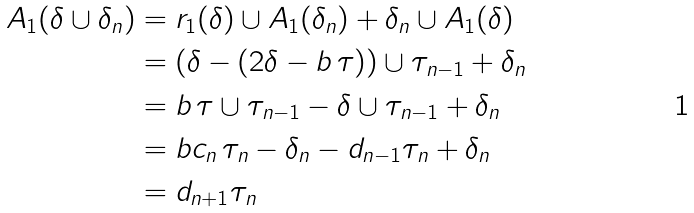Convert formula to latex. <formula><loc_0><loc_0><loc_500><loc_500>A _ { 1 } ( \delta \cup \delta _ { n } ) & = r _ { 1 } ( \delta ) \cup A _ { 1 } ( \delta _ { n } ) + \delta _ { n } \cup A _ { 1 } ( \delta ) \\ & = ( \delta - ( 2 \delta - b \, \tau ) ) \cup \tau _ { n - 1 } + \delta _ { n } \\ & = b \, \tau \cup \tau _ { n - 1 } - \delta \cup \tau _ { n - 1 } + \delta _ { n } \\ & = b c _ { n } \, \tau _ { n } - \delta _ { n } - d _ { n - 1 } \tau _ { n } + \delta _ { n } \\ & = d _ { n + 1 } \tau _ { n }</formula> 